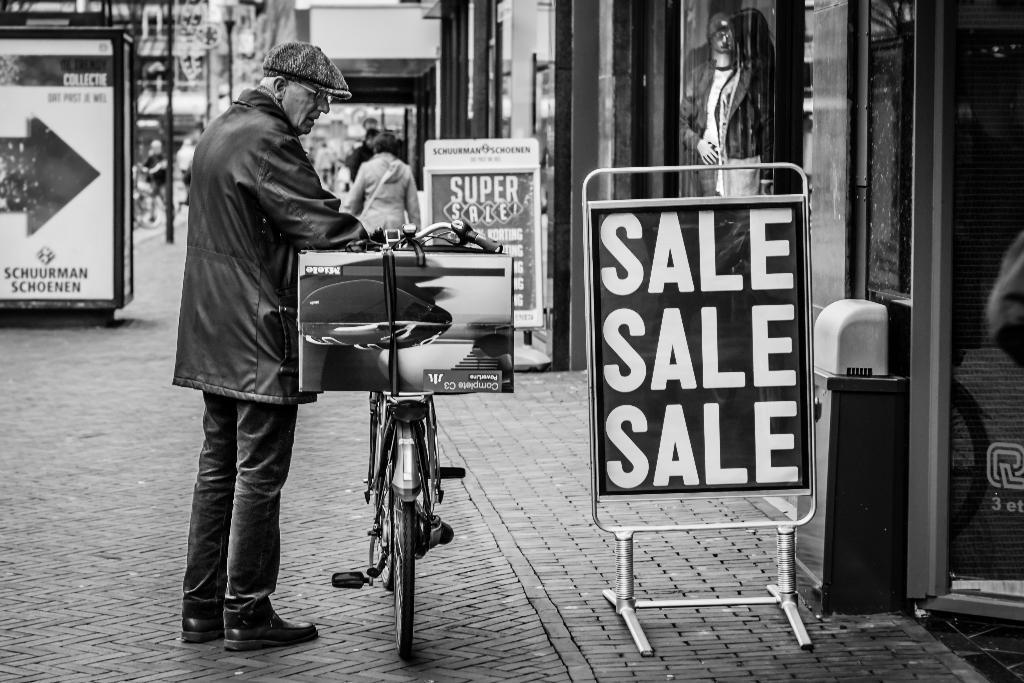In one or two sentences, can you explain what this image depicts? It is a black and white picture, there are many stores and in front of the stores there are some words containing the text of "sale" and there is an old man standing in front of one of the store by holding a cycle and the background of the old man is blur. 